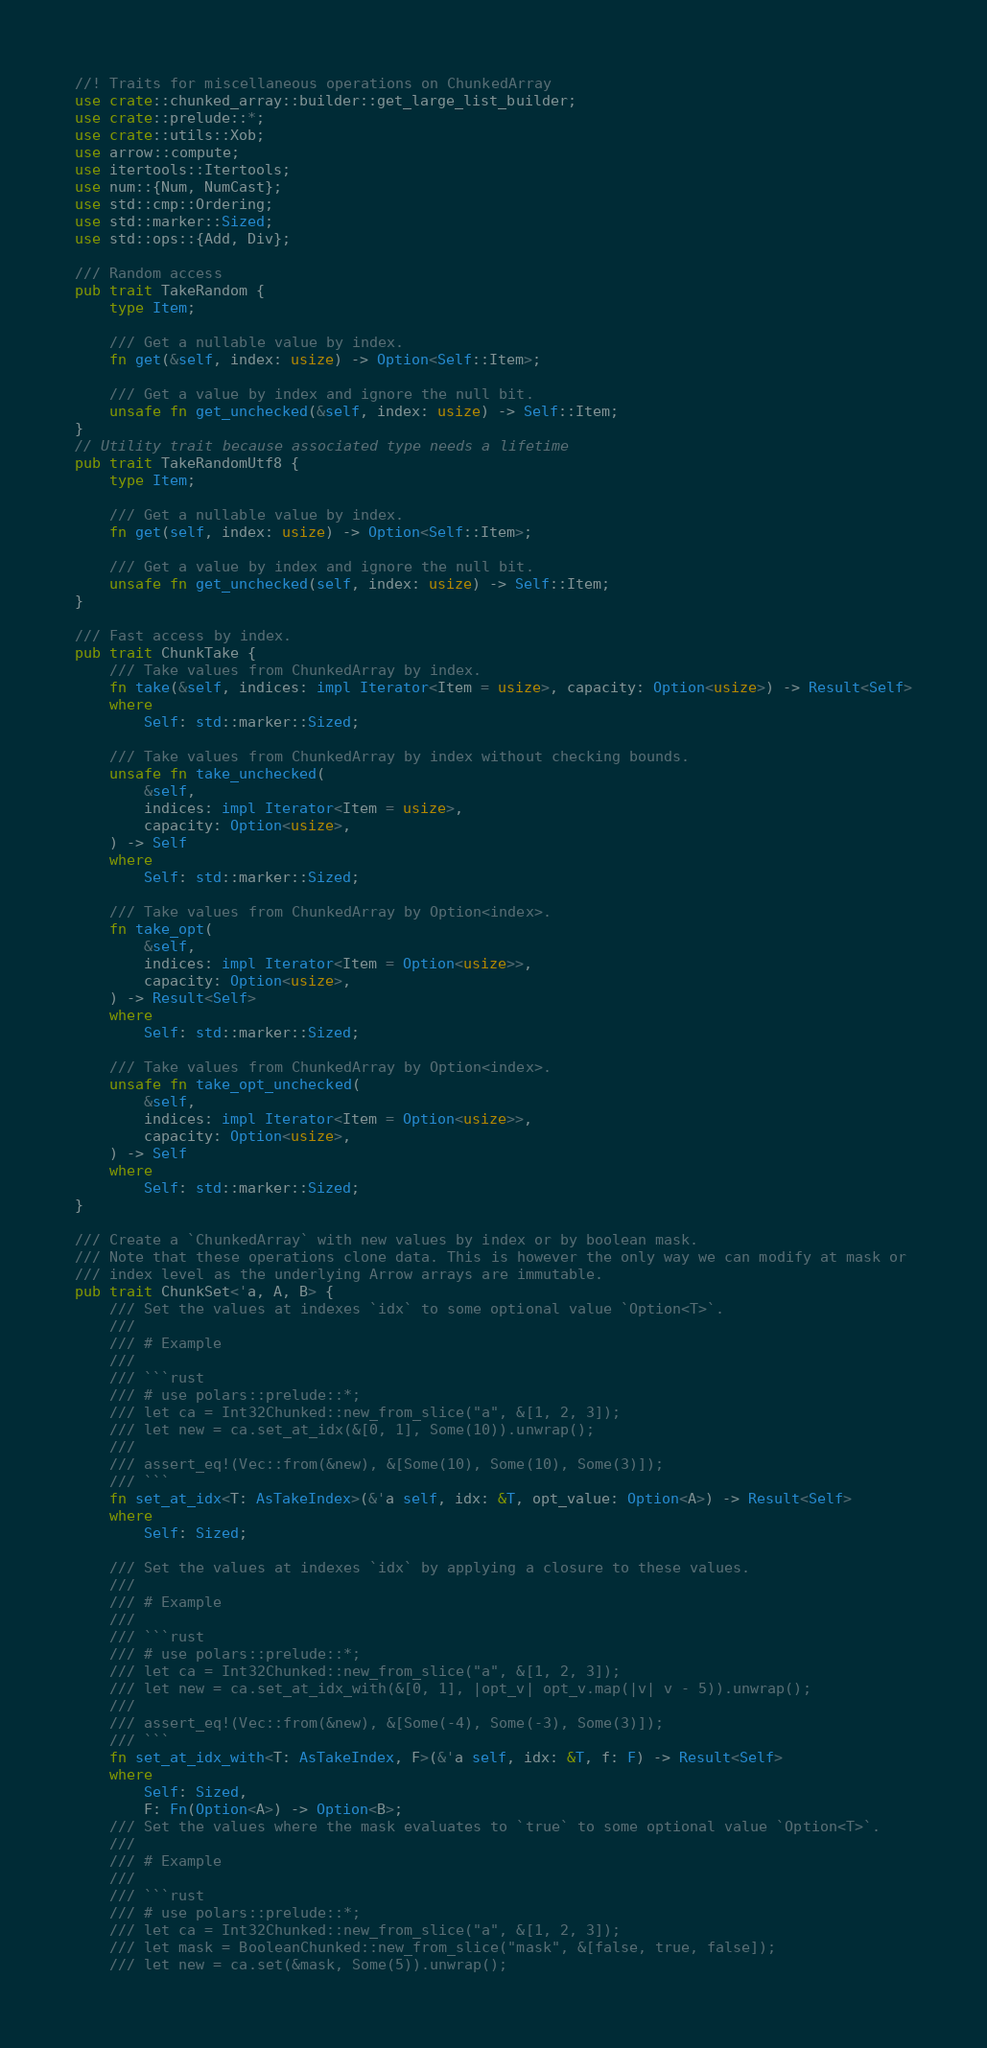<code> <loc_0><loc_0><loc_500><loc_500><_Rust_>//! Traits for miscellaneous operations on ChunkedArray
use crate::chunked_array::builder::get_large_list_builder;
use crate::prelude::*;
use crate::utils::Xob;
use arrow::compute;
use itertools::Itertools;
use num::{Num, NumCast};
use std::cmp::Ordering;
use std::marker::Sized;
use std::ops::{Add, Div};

/// Random access
pub trait TakeRandom {
    type Item;

    /// Get a nullable value by index.
    fn get(&self, index: usize) -> Option<Self::Item>;

    /// Get a value by index and ignore the null bit.
    unsafe fn get_unchecked(&self, index: usize) -> Self::Item;
}
// Utility trait because associated type needs a lifetime
pub trait TakeRandomUtf8 {
    type Item;

    /// Get a nullable value by index.
    fn get(self, index: usize) -> Option<Self::Item>;

    /// Get a value by index and ignore the null bit.
    unsafe fn get_unchecked(self, index: usize) -> Self::Item;
}

/// Fast access by index.
pub trait ChunkTake {
    /// Take values from ChunkedArray by index.
    fn take(&self, indices: impl Iterator<Item = usize>, capacity: Option<usize>) -> Result<Self>
    where
        Self: std::marker::Sized;

    /// Take values from ChunkedArray by index without checking bounds.
    unsafe fn take_unchecked(
        &self,
        indices: impl Iterator<Item = usize>,
        capacity: Option<usize>,
    ) -> Self
    where
        Self: std::marker::Sized;

    /// Take values from ChunkedArray by Option<index>.
    fn take_opt(
        &self,
        indices: impl Iterator<Item = Option<usize>>,
        capacity: Option<usize>,
    ) -> Result<Self>
    where
        Self: std::marker::Sized;

    /// Take values from ChunkedArray by Option<index>.
    unsafe fn take_opt_unchecked(
        &self,
        indices: impl Iterator<Item = Option<usize>>,
        capacity: Option<usize>,
    ) -> Self
    where
        Self: std::marker::Sized;
}

/// Create a `ChunkedArray` with new values by index or by boolean mask.
/// Note that these operations clone data. This is however the only way we can modify at mask or
/// index level as the underlying Arrow arrays are immutable.
pub trait ChunkSet<'a, A, B> {
    /// Set the values at indexes `idx` to some optional value `Option<T>`.
    ///
    /// # Example
    ///
    /// ```rust
    /// # use polars::prelude::*;
    /// let ca = Int32Chunked::new_from_slice("a", &[1, 2, 3]);
    /// let new = ca.set_at_idx(&[0, 1], Some(10)).unwrap();
    ///
    /// assert_eq!(Vec::from(&new), &[Some(10), Some(10), Some(3)]);
    /// ```
    fn set_at_idx<T: AsTakeIndex>(&'a self, idx: &T, opt_value: Option<A>) -> Result<Self>
    where
        Self: Sized;

    /// Set the values at indexes `idx` by applying a closure to these values.
    ///
    /// # Example
    ///
    /// ```rust
    /// # use polars::prelude::*;
    /// let ca = Int32Chunked::new_from_slice("a", &[1, 2, 3]);
    /// let new = ca.set_at_idx_with(&[0, 1], |opt_v| opt_v.map(|v| v - 5)).unwrap();
    ///
    /// assert_eq!(Vec::from(&new), &[Some(-4), Some(-3), Some(3)]);
    /// ```
    fn set_at_idx_with<T: AsTakeIndex, F>(&'a self, idx: &T, f: F) -> Result<Self>
    where
        Self: Sized,
        F: Fn(Option<A>) -> Option<B>;
    /// Set the values where the mask evaluates to `true` to some optional value `Option<T>`.
    ///
    /// # Example
    ///
    /// ```rust
    /// # use polars::prelude::*;
    /// let ca = Int32Chunked::new_from_slice("a", &[1, 2, 3]);
    /// let mask = BooleanChunked::new_from_slice("mask", &[false, true, false]);
    /// let new = ca.set(&mask, Some(5)).unwrap();</code> 